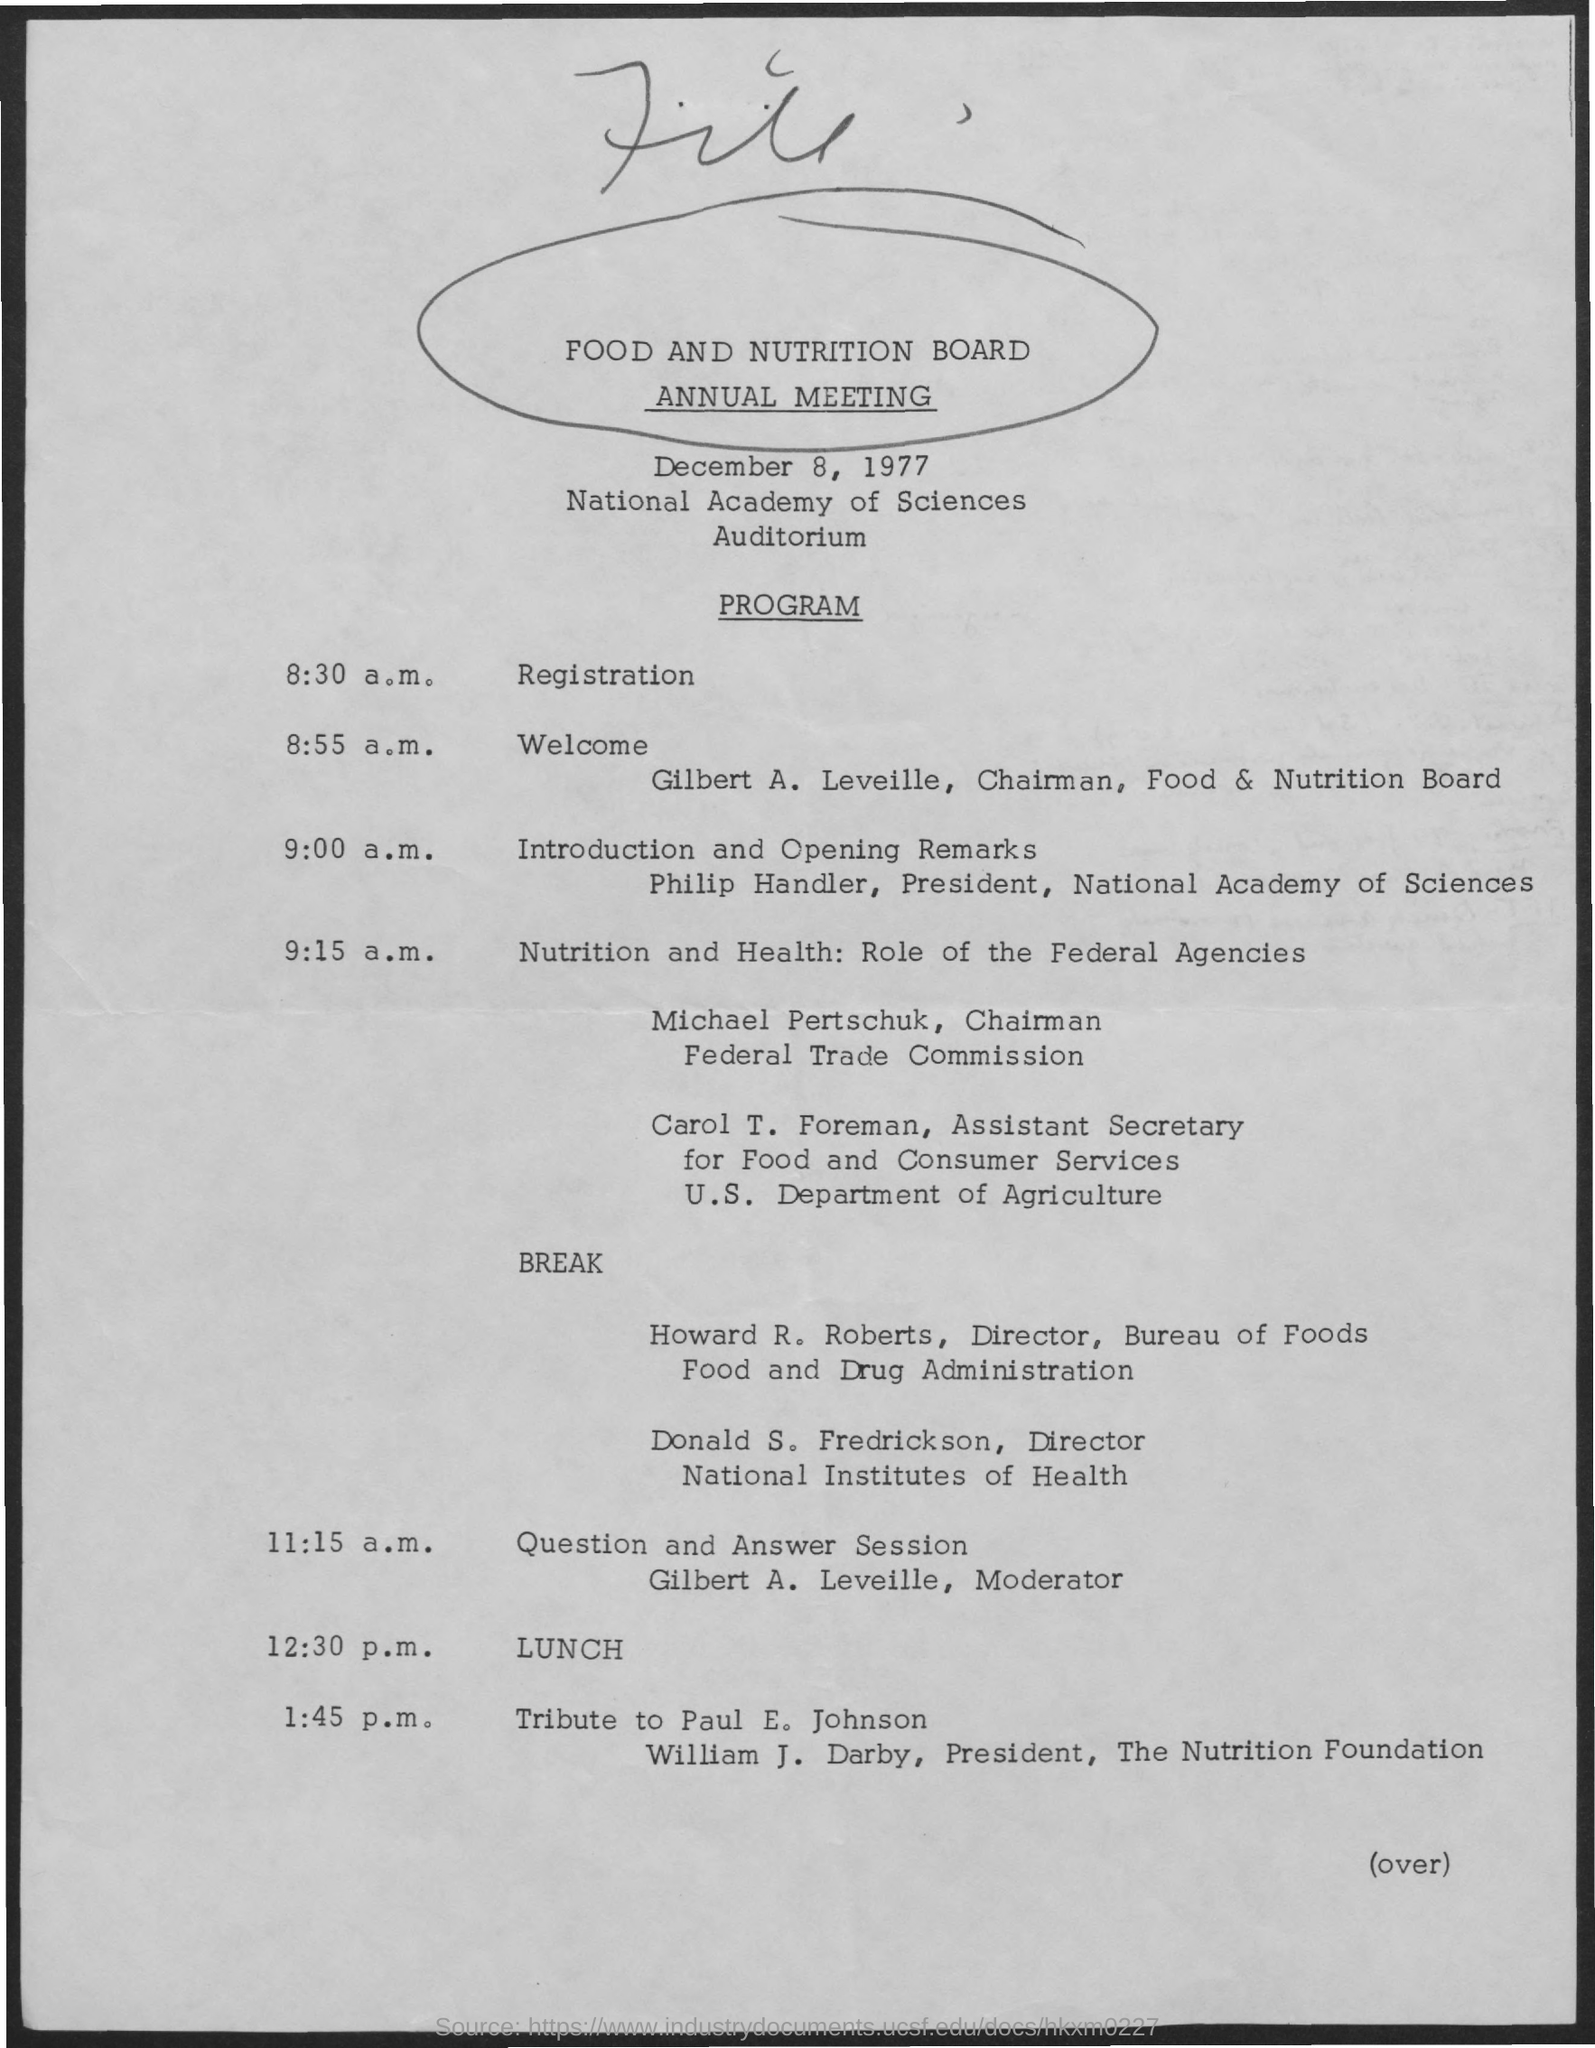Draw attention to some important aspects in this diagram. The chairman of the Federal Trade Commission is Michael Pertschuk. The moderator of the Question and Answer Session is Gilbert A. Leveille. The president of the Nutrition Foundation is William J. Darby. 